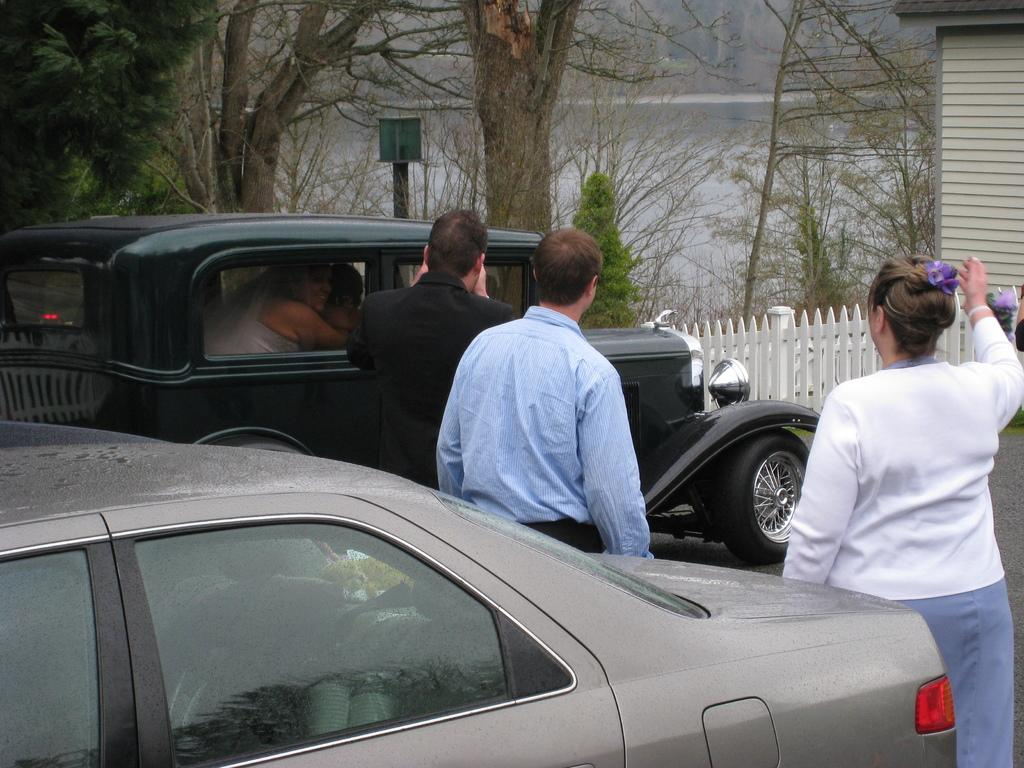How many cars are in the image? There are two cars in the image. What color is one of the cars? One of the cars is black. Who is inside the black car? There is a lady inside the black car. How many people are standing outside the black car? There are three people standing outside the black car. What type of vegetation is present in the image? There are plants and trees in the image. What natural element is visible in the image? There is water visible in the image. Who is the creator of the cake seen in the image? There is no cake present in the image, so it is not possible to determine who the creator might be. 